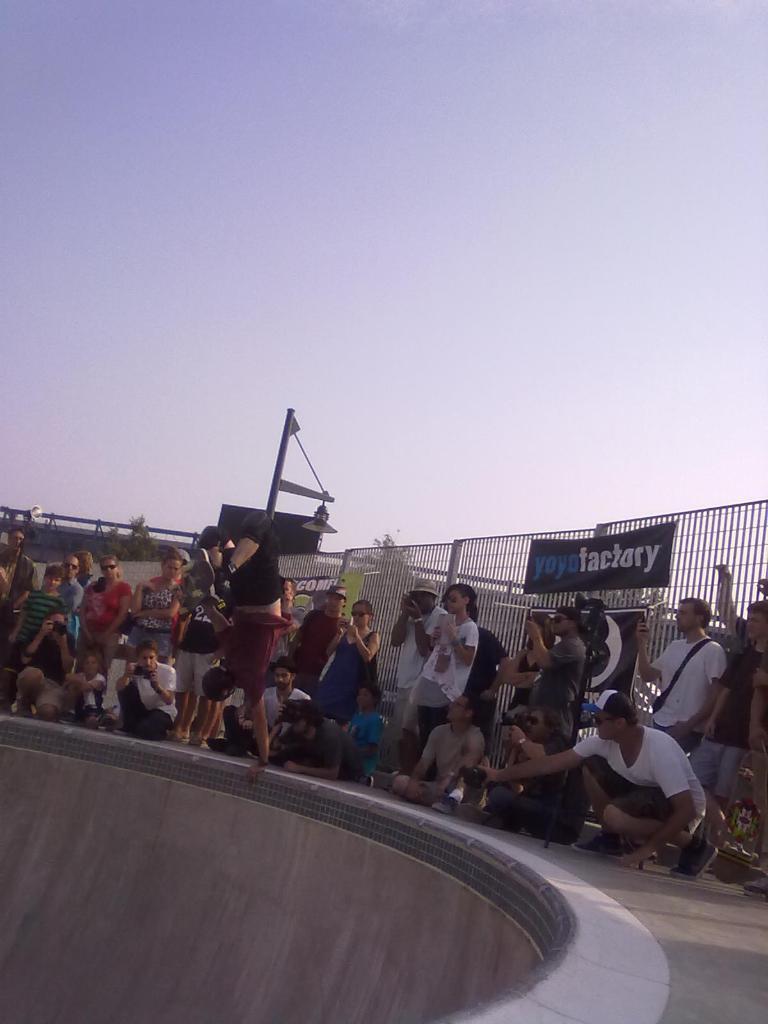Could you give a brief overview of what you see in this image? In this image I can see group of people. In the background I can see the railing and the sky is in blue and white color. 